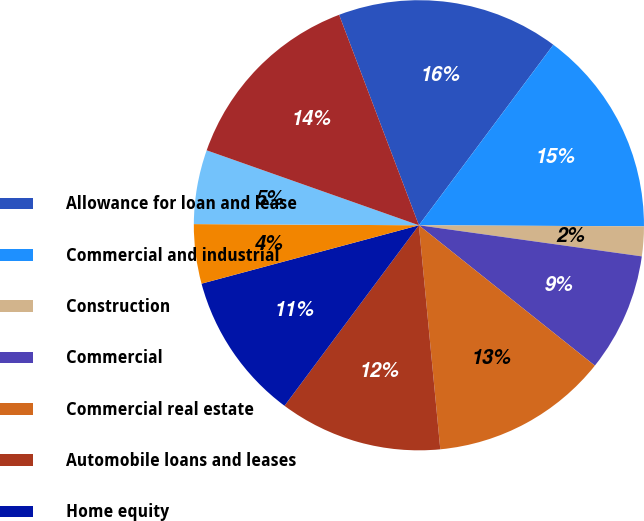Convert chart. <chart><loc_0><loc_0><loc_500><loc_500><pie_chart><fcel>Allowance for loan and lease<fcel>Commercial and industrial<fcel>Construction<fcel>Commercial<fcel>Commercial real estate<fcel>Automobile loans and leases<fcel>Home equity<fcel>Residential mortgage<fcel>Other loans<fcel>Total consumer<nl><fcel>15.96%<fcel>14.89%<fcel>2.13%<fcel>8.51%<fcel>12.77%<fcel>11.7%<fcel>10.64%<fcel>4.26%<fcel>5.32%<fcel>13.83%<nl></chart> 